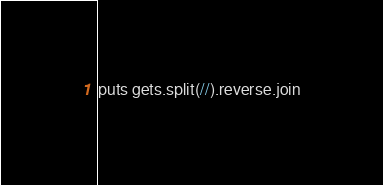<code> <loc_0><loc_0><loc_500><loc_500><_Ruby_>puts gets.split(//).reverse.join</code> 